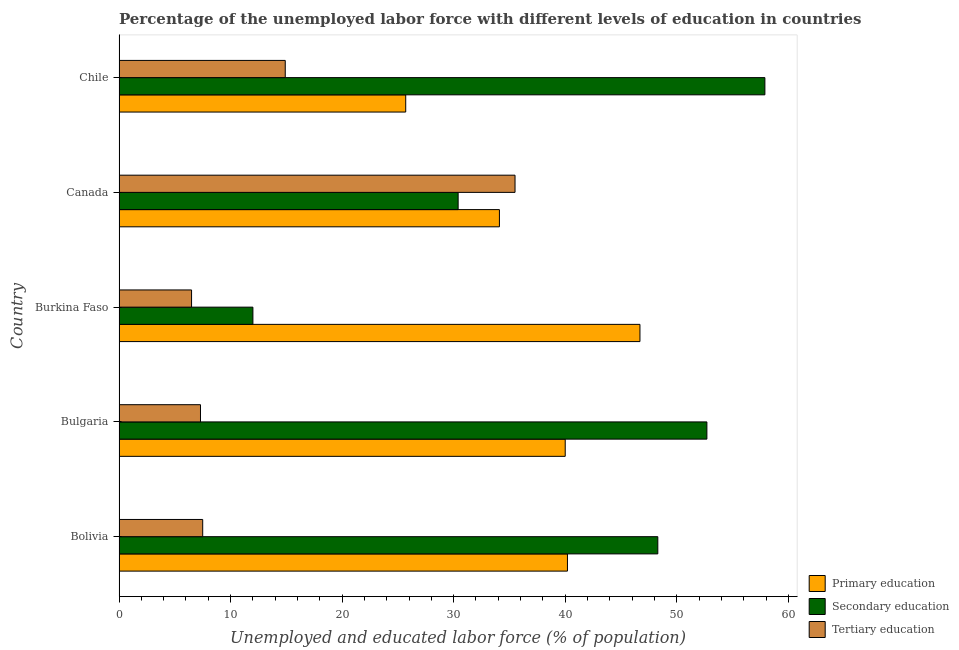How many different coloured bars are there?
Provide a short and direct response. 3. How many bars are there on the 4th tick from the bottom?
Provide a succinct answer. 3. What is the label of the 1st group of bars from the top?
Make the answer very short. Chile. In how many cases, is the number of bars for a given country not equal to the number of legend labels?
Give a very brief answer. 0. What is the percentage of labor force who received secondary education in Canada?
Ensure brevity in your answer.  30.4. Across all countries, what is the maximum percentage of labor force who received tertiary education?
Provide a succinct answer. 35.5. Across all countries, what is the minimum percentage of labor force who received tertiary education?
Offer a terse response. 6.5. In which country was the percentage of labor force who received tertiary education maximum?
Your response must be concise. Canada. In which country was the percentage of labor force who received secondary education minimum?
Provide a short and direct response. Burkina Faso. What is the total percentage of labor force who received secondary education in the graph?
Make the answer very short. 201.3. What is the difference between the percentage of labor force who received tertiary education in Bolivia and that in Bulgaria?
Your response must be concise. 0.2. What is the difference between the percentage of labor force who received primary education in Bulgaria and the percentage of labor force who received secondary education in Bolivia?
Your answer should be very brief. -8.3. What is the average percentage of labor force who received tertiary education per country?
Your answer should be very brief. 14.34. In how many countries, is the percentage of labor force who received tertiary education greater than 20 %?
Offer a very short reply. 1. What is the ratio of the percentage of labor force who received primary education in Burkina Faso to that in Chile?
Give a very brief answer. 1.82. Is the percentage of labor force who received tertiary education in Bolivia less than that in Burkina Faso?
Your answer should be compact. No. What is the difference between the highest and the second highest percentage of labor force who received tertiary education?
Provide a short and direct response. 20.6. What does the 2nd bar from the top in Bulgaria represents?
Your answer should be very brief. Secondary education. What does the 2nd bar from the bottom in Bolivia represents?
Your answer should be very brief. Secondary education. Is it the case that in every country, the sum of the percentage of labor force who received primary education and percentage of labor force who received secondary education is greater than the percentage of labor force who received tertiary education?
Your answer should be compact. Yes. How many countries are there in the graph?
Give a very brief answer. 5. What is the difference between two consecutive major ticks on the X-axis?
Make the answer very short. 10. Does the graph contain any zero values?
Make the answer very short. No. Where does the legend appear in the graph?
Provide a short and direct response. Bottom right. How many legend labels are there?
Make the answer very short. 3. How are the legend labels stacked?
Provide a short and direct response. Vertical. What is the title of the graph?
Ensure brevity in your answer.  Percentage of the unemployed labor force with different levels of education in countries. Does "Social Insurance" appear as one of the legend labels in the graph?
Keep it short and to the point. No. What is the label or title of the X-axis?
Offer a terse response. Unemployed and educated labor force (% of population). What is the label or title of the Y-axis?
Your answer should be compact. Country. What is the Unemployed and educated labor force (% of population) in Primary education in Bolivia?
Your answer should be compact. 40.2. What is the Unemployed and educated labor force (% of population) of Secondary education in Bolivia?
Keep it short and to the point. 48.3. What is the Unemployed and educated labor force (% of population) of Tertiary education in Bolivia?
Offer a terse response. 7.5. What is the Unemployed and educated labor force (% of population) in Secondary education in Bulgaria?
Give a very brief answer. 52.7. What is the Unemployed and educated labor force (% of population) of Tertiary education in Bulgaria?
Give a very brief answer. 7.3. What is the Unemployed and educated labor force (% of population) in Primary education in Burkina Faso?
Your response must be concise. 46.7. What is the Unemployed and educated labor force (% of population) in Secondary education in Burkina Faso?
Give a very brief answer. 12. What is the Unemployed and educated labor force (% of population) in Tertiary education in Burkina Faso?
Give a very brief answer. 6.5. What is the Unemployed and educated labor force (% of population) in Primary education in Canada?
Keep it short and to the point. 34.1. What is the Unemployed and educated labor force (% of population) of Secondary education in Canada?
Make the answer very short. 30.4. What is the Unemployed and educated labor force (% of population) of Tertiary education in Canada?
Provide a succinct answer. 35.5. What is the Unemployed and educated labor force (% of population) of Primary education in Chile?
Offer a terse response. 25.7. What is the Unemployed and educated labor force (% of population) of Secondary education in Chile?
Provide a succinct answer. 57.9. What is the Unemployed and educated labor force (% of population) of Tertiary education in Chile?
Your answer should be very brief. 14.9. Across all countries, what is the maximum Unemployed and educated labor force (% of population) in Primary education?
Your answer should be very brief. 46.7. Across all countries, what is the maximum Unemployed and educated labor force (% of population) of Secondary education?
Provide a short and direct response. 57.9. Across all countries, what is the maximum Unemployed and educated labor force (% of population) in Tertiary education?
Your response must be concise. 35.5. Across all countries, what is the minimum Unemployed and educated labor force (% of population) of Primary education?
Provide a short and direct response. 25.7. What is the total Unemployed and educated labor force (% of population) of Primary education in the graph?
Your answer should be compact. 186.7. What is the total Unemployed and educated labor force (% of population) in Secondary education in the graph?
Offer a terse response. 201.3. What is the total Unemployed and educated labor force (% of population) of Tertiary education in the graph?
Provide a short and direct response. 71.7. What is the difference between the Unemployed and educated labor force (% of population) of Secondary education in Bolivia and that in Bulgaria?
Offer a terse response. -4.4. What is the difference between the Unemployed and educated labor force (% of population) in Tertiary education in Bolivia and that in Bulgaria?
Offer a very short reply. 0.2. What is the difference between the Unemployed and educated labor force (% of population) in Primary education in Bolivia and that in Burkina Faso?
Offer a terse response. -6.5. What is the difference between the Unemployed and educated labor force (% of population) of Secondary education in Bolivia and that in Burkina Faso?
Provide a succinct answer. 36.3. What is the difference between the Unemployed and educated labor force (% of population) of Tertiary education in Bolivia and that in Burkina Faso?
Offer a terse response. 1. What is the difference between the Unemployed and educated labor force (% of population) in Primary education in Bolivia and that in Canada?
Provide a succinct answer. 6.1. What is the difference between the Unemployed and educated labor force (% of population) in Secondary education in Bolivia and that in Canada?
Ensure brevity in your answer.  17.9. What is the difference between the Unemployed and educated labor force (% of population) of Tertiary education in Bolivia and that in Canada?
Offer a terse response. -28. What is the difference between the Unemployed and educated labor force (% of population) in Secondary education in Bolivia and that in Chile?
Provide a short and direct response. -9.6. What is the difference between the Unemployed and educated labor force (% of population) of Tertiary education in Bolivia and that in Chile?
Give a very brief answer. -7.4. What is the difference between the Unemployed and educated labor force (% of population) of Secondary education in Bulgaria and that in Burkina Faso?
Provide a short and direct response. 40.7. What is the difference between the Unemployed and educated labor force (% of population) in Tertiary education in Bulgaria and that in Burkina Faso?
Offer a terse response. 0.8. What is the difference between the Unemployed and educated labor force (% of population) of Primary education in Bulgaria and that in Canada?
Keep it short and to the point. 5.9. What is the difference between the Unemployed and educated labor force (% of population) in Secondary education in Bulgaria and that in Canada?
Your answer should be compact. 22.3. What is the difference between the Unemployed and educated labor force (% of population) of Tertiary education in Bulgaria and that in Canada?
Keep it short and to the point. -28.2. What is the difference between the Unemployed and educated labor force (% of population) of Secondary education in Burkina Faso and that in Canada?
Provide a succinct answer. -18.4. What is the difference between the Unemployed and educated labor force (% of population) of Tertiary education in Burkina Faso and that in Canada?
Keep it short and to the point. -29. What is the difference between the Unemployed and educated labor force (% of population) in Secondary education in Burkina Faso and that in Chile?
Offer a very short reply. -45.9. What is the difference between the Unemployed and educated labor force (% of population) in Secondary education in Canada and that in Chile?
Provide a short and direct response. -27.5. What is the difference between the Unemployed and educated labor force (% of population) in Tertiary education in Canada and that in Chile?
Offer a very short reply. 20.6. What is the difference between the Unemployed and educated labor force (% of population) of Primary education in Bolivia and the Unemployed and educated labor force (% of population) of Tertiary education in Bulgaria?
Your response must be concise. 32.9. What is the difference between the Unemployed and educated labor force (% of population) of Primary education in Bolivia and the Unemployed and educated labor force (% of population) of Secondary education in Burkina Faso?
Give a very brief answer. 28.2. What is the difference between the Unemployed and educated labor force (% of population) in Primary education in Bolivia and the Unemployed and educated labor force (% of population) in Tertiary education in Burkina Faso?
Provide a short and direct response. 33.7. What is the difference between the Unemployed and educated labor force (% of population) in Secondary education in Bolivia and the Unemployed and educated labor force (% of population) in Tertiary education in Burkina Faso?
Provide a succinct answer. 41.8. What is the difference between the Unemployed and educated labor force (% of population) in Primary education in Bolivia and the Unemployed and educated labor force (% of population) in Secondary education in Canada?
Offer a very short reply. 9.8. What is the difference between the Unemployed and educated labor force (% of population) in Secondary education in Bolivia and the Unemployed and educated labor force (% of population) in Tertiary education in Canada?
Give a very brief answer. 12.8. What is the difference between the Unemployed and educated labor force (% of population) in Primary education in Bolivia and the Unemployed and educated labor force (% of population) in Secondary education in Chile?
Give a very brief answer. -17.7. What is the difference between the Unemployed and educated labor force (% of population) of Primary education in Bolivia and the Unemployed and educated labor force (% of population) of Tertiary education in Chile?
Your response must be concise. 25.3. What is the difference between the Unemployed and educated labor force (% of population) of Secondary education in Bolivia and the Unemployed and educated labor force (% of population) of Tertiary education in Chile?
Your response must be concise. 33.4. What is the difference between the Unemployed and educated labor force (% of population) of Primary education in Bulgaria and the Unemployed and educated labor force (% of population) of Secondary education in Burkina Faso?
Make the answer very short. 28. What is the difference between the Unemployed and educated labor force (% of population) in Primary education in Bulgaria and the Unemployed and educated labor force (% of population) in Tertiary education in Burkina Faso?
Provide a short and direct response. 33.5. What is the difference between the Unemployed and educated labor force (% of population) in Secondary education in Bulgaria and the Unemployed and educated labor force (% of population) in Tertiary education in Burkina Faso?
Keep it short and to the point. 46.2. What is the difference between the Unemployed and educated labor force (% of population) of Primary education in Bulgaria and the Unemployed and educated labor force (% of population) of Secondary education in Canada?
Provide a short and direct response. 9.6. What is the difference between the Unemployed and educated labor force (% of population) in Secondary education in Bulgaria and the Unemployed and educated labor force (% of population) in Tertiary education in Canada?
Make the answer very short. 17.2. What is the difference between the Unemployed and educated labor force (% of population) in Primary education in Bulgaria and the Unemployed and educated labor force (% of population) in Secondary education in Chile?
Provide a succinct answer. -17.9. What is the difference between the Unemployed and educated labor force (% of population) of Primary education in Bulgaria and the Unemployed and educated labor force (% of population) of Tertiary education in Chile?
Offer a very short reply. 25.1. What is the difference between the Unemployed and educated labor force (% of population) in Secondary education in Bulgaria and the Unemployed and educated labor force (% of population) in Tertiary education in Chile?
Provide a short and direct response. 37.8. What is the difference between the Unemployed and educated labor force (% of population) in Primary education in Burkina Faso and the Unemployed and educated labor force (% of population) in Secondary education in Canada?
Ensure brevity in your answer.  16.3. What is the difference between the Unemployed and educated labor force (% of population) in Secondary education in Burkina Faso and the Unemployed and educated labor force (% of population) in Tertiary education in Canada?
Ensure brevity in your answer.  -23.5. What is the difference between the Unemployed and educated labor force (% of population) in Primary education in Burkina Faso and the Unemployed and educated labor force (% of population) in Tertiary education in Chile?
Your answer should be compact. 31.8. What is the difference between the Unemployed and educated labor force (% of population) in Secondary education in Burkina Faso and the Unemployed and educated labor force (% of population) in Tertiary education in Chile?
Provide a short and direct response. -2.9. What is the difference between the Unemployed and educated labor force (% of population) in Primary education in Canada and the Unemployed and educated labor force (% of population) in Secondary education in Chile?
Provide a succinct answer. -23.8. What is the difference between the Unemployed and educated labor force (% of population) of Primary education in Canada and the Unemployed and educated labor force (% of population) of Tertiary education in Chile?
Ensure brevity in your answer.  19.2. What is the difference between the Unemployed and educated labor force (% of population) of Secondary education in Canada and the Unemployed and educated labor force (% of population) of Tertiary education in Chile?
Provide a succinct answer. 15.5. What is the average Unemployed and educated labor force (% of population) of Primary education per country?
Give a very brief answer. 37.34. What is the average Unemployed and educated labor force (% of population) in Secondary education per country?
Your answer should be compact. 40.26. What is the average Unemployed and educated labor force (% of population) in Tertiary education per country?
Provide a succinct answer. 14.34. What is the difference between the Unemployed and educated labor force (% of population) in Primary education and Unemployed and educated labor force (% of population) in Secondary education in Bolivia?
Your answer should be compact. -8.1. What is the difference between the Unemployed and educated labor force (% of population) of Primary education and Unemployed and educated labor force (% of population) of Tertiary education in Bolivia?
Keep it short and to the point. 32.7. What is the difference between the Unemployed and educated labor force (% of population) in Secondary education and Unemployed and educated labor force (% of population) in Tertiary education in Bolivia?
Make the answer very short. 40.8. What is the difference between the Unemployed and educated labor force (% of population) in Primary education and Unemployed and educated labor force (% of population) in Secondary education in Bulgaria?
Provide a succinct answer. -12.7. What is the difference between the Unemployed and educated labor force (% of population) of Primary education and Unemployed and educated labor force (% of population) of Tertiary education in Bulgaria?
Offer a terse response. 32.7. What is the difference between the Unemployed and educated labor force (% of population) of Secondary education and Unemployed and educated labor force (% of population) of Tertiary education in Bulgaria?
Make the answer very short. 45.4. What is the difference between the Unemployed and educated labor force (% of population) in Primary education and Unemployed and educated labor force (% of population) in Secondary education in Burkina Faso?
Provide a short and direct response. 34.7. What is the difference between the Unemployed and educated labor force (% of population) in Primary education and Unemployed and educated labor force (% of population) in Tertiary education in Burkina Faso?
Offer a terse response. 40.2. What is the difference between the Unemployed and educated labor force (% of population) of Secondary education and Unemployed and educated labor force (% of population) of Tertiary education in Burkina Faso?
Your answer should be compact. 5.5. What is the difference between the Unemployed and educated labor force (% of population) of Primary education and Unemployed and educated labor force (% of population) of Tertiary education in Canada?
Ensure brevity in your answer.  -1.4. What is the difference between the Unemployed and educated labor force (% of population) in Primary education and Unemployed and educated labor force (% of population) in Secondary education in Chile?
Your answer should be compact. -32.2. What is the ratio of the Unemployed and educated labor force (% of population) in Primary education in Bolivia to that in Bulgaria?
Your response must be concise. 1. What is the ratio of the Unemployed and educated labor force (% of population) of Secondary education in Bolivia to that in Bulgaria?
Offer a terse response. 0.92. What is the ratio of the Unemployed and educated labor force (% of population) in Tertiary education in Bolivia to that in Bulgaria?
Your answer should be compact. 1.03. What is the ratio of the Unemployed and educated labor force (% of population) in Primary education in Bolivia to that in Burkina Faso?
Provide a succinct answer. 0.86. What is the ratio of the Unemployed and educated labor force (% of population) of Secondary education in Bolivia to that in Burkina Faso?
Provide a succinct answer. 4.03. What is the ratio of the Unemployed and educated labor force (% of population) in Tertiary education in Bolivia to that in Burkina Faso?
Your response must be concise. 1.15. What is the ratio of the Unemployed and educated labor force (% of population) of Primary education in Bolivia to that in Canada?
Offer a terse response. 1.18. What is the ratio of the Unemployed and educated labor force (% of population) of Secondary education in Bolivia to that in Canada?
Provide a succinct answer. 1.59. What is the ratio of the Unemployed and educated labor force (% of population) of Tertiary education in Bolivia to that in Canada?
Offer a very short reply. 0.21. What is the ratio of the Unemployed and educated labor force (% of population) of Primary education in Bolivia to that in Chile?
Ensure brevity in your answer.  1.56. What is the ratio of the Unemployed and educated labor force (% of population) of Secondary education in Bolivia to that in Chile?
Your response must be concise. 0.83. What is the ratio of the Unemployed and educated labor force (% of population) in Tertiary education in Bolivia to that in Chile?
Provide a succinct answer. 0.5. What is the ratio of the Unemployed and educated labor force (% of population) of Primary education in Bulgaria to that in Burkina Faso?
Your response must be concise. 0.86. What is the ratio of the Unemployed and educated labor force (% of population) in Secondary education in Bulgaria to that in Burkina Faso?
Give a very brief answer. 4.39. What is the ratio of the Unemployed and educated labor force (% of population) in Tertiary education in Bulgaria to that in Burkina Faso?
Provide a short and direct response. 1.12. What is the ratio of the Unemployed and educated labor force (% of population) of Primary education in Bulgaria to that in Canada?
Give a very brief answer. 1.17. What is the ratio of the Unemployed and educated labor force (% of population) in Secondary education in Bulgaria to that in Canada?
Your answer should be very brief. 1.73. What is the ratio of the Unemployed and educated labor force (% of population) in Tertiary education in Bulgaria to that in Canada?
Ensure brevity in your answer.  0.21. What is the ratio of the Unemployed and educated labor force (% of population) of Primary education in Bulgaria to that in Chile?
Offer a terse response. 1.56. What is the ratio of the Unemployed and educated labor force (% of population) of Secondary education in Bulgaria to that in Chile?
Give a very brief answer. 0.91. What is the ratio of the Unemployed and educated labor force (% of population) in Tertiary education in Bulgaria to that in Chile?
Offer a very short reply. 0.49. What is the ratio of the Unemployed and educated labor force (% of population) in Primary education in Burkina Faso to that in Canada?
Your answer should be compact. 1.37. What is the ratio of the Unemployed and educated labor force (% of population) of Secondary education in Burkina Faso to that in Canada?
Ensure brevity in your answer.  0.39. What is the ratio of the Unemployed and educated labor force (% of population) of Tertiary education in Burkina Faso to that in Canada?
Keep it short and to the point. 0.18. What is the ratio of the Unemployed and educated labor force (% of population) of Primary education in Burkina Faso to that in Chile?
Offer a very short reply. 1.82. What is the ratio of the Unemployed and educated labor force (% of population) in Secondary education in Burkina Faso to that in Chile?
Your response must be concise. 0.21. What is the ratio of the Unemployed and educated labor force (% of population) in Tertiary education in Burkina Faso to that in Chile?
Make the answer very short. 0.44. What is the ratio of the Unemployed and educated labor force (% of population) in Primary education in Canada to that in Chile?
Your response must be concise. 1.33. What is the ratio of the Unemployed and educated labor force (% of population) of Secondary education in Canada to that in Chile?
Offer a very short reply. 0.53. What is the ratio of the Unemployed and educated labor force (% of population) of Tertiary education in Canada to that in Chile?
Keep it short and to the point. 2.38. What is the difference between the highest and the second highest Unemployed and educated labor force (% of population) of Primary education?
Your answer should be compact. 6.5. What is the difference between the highest and the second highest Unemployed and educated labor force (% of population) of Tertiary education?
Your answer should be compact. 20.6. What is the difference between the highest and the lowest Unemployed and educated labor force (% of population) in Secondary education?
Provide a short and direct response. 45.9. 